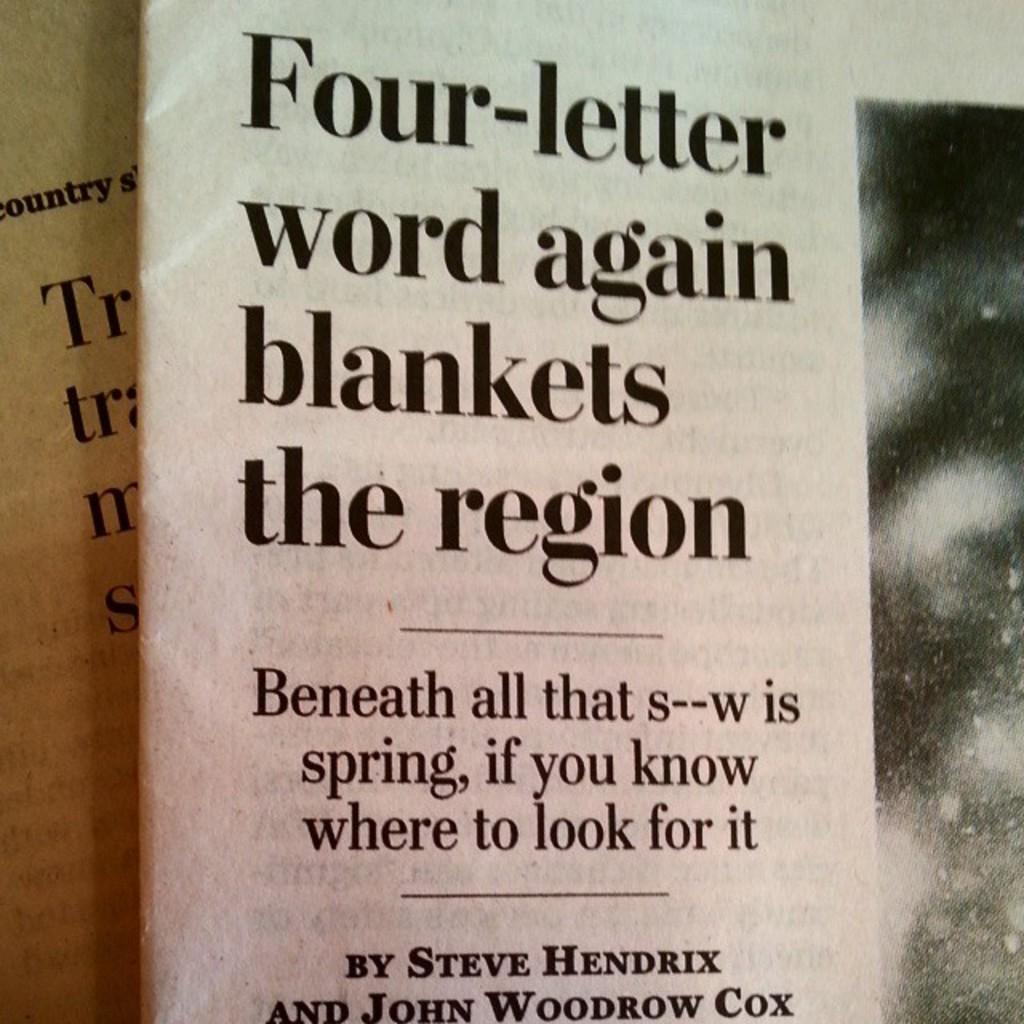<image>
Write a terse but informative summary of the picture. an article about snow coming is written in a newspaper 